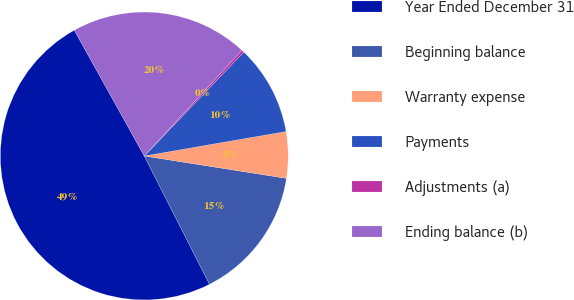Convert chart. <chart><loc_0><loc_0><loc_500><loc_500><pie_chart><fcel>Year Ended December 31<fcel>Beginning balance<fcel>Warranty expense<fcel>Payments<fcel>Adjustments (a)<fcel>Ending balance (b)<nl><fcel>49.41%<fcel>15.03%<fcel>5.21%<fcel>10.12%<fcel>0.3%<fcel>19.94%<nl></chart> 